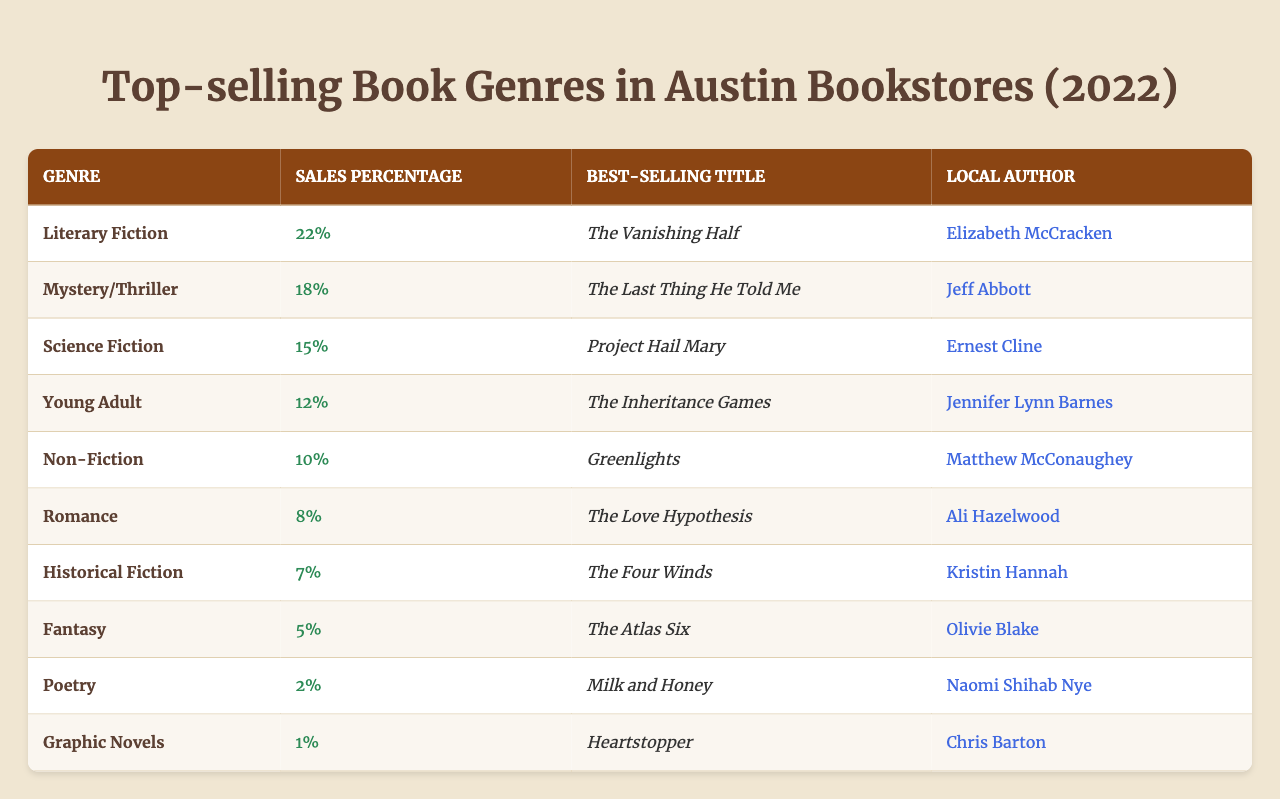What is the best-selling title in the Mystery/Thriller genre? Referring to the table, the row for the Mystery/Thriller genre shows that the best-selling title is "The Last Thing He Told Me."
Answer: The Last Thing He Told Me Which genre has the highest sales percentage? The table lists the Literary Fiction genre with a sales percentage of 22%, which is the highest among all listed genres.
Answer: Literary Fiction How many genres have a sales percentage of 10% or more? By reviewing the table, I can count the genres with sales percentages of 10% or more: Literary Fiction (22%), Mystery/Thriller (18%), Science Fiction (15%), Young Adult (12%), and Non-Fiction (10%). This gives a total of 5 genres.
Answer: 5 Is there a local author for the Fantasy genre? Looking at the table, the Fantasy genre does have a local author listed: Olivie Blake. Therefore, the answer is yes.
Answer: Yes What is the sales percentage difference between Literary Fiction and Poetry? To find the difference, I subtract the sales percentage for Poetry (2%) from Literary Fiction (22%): 22% - 2% = 20%.
Answer: 20% Which genre has the lowest sales percentage and who is the author? Scanning through the table, Graphic Novels have the lowest sales percentage of 1% and the author listed is Chris Barton.
Answer: Graphic Novels, Chris Barton What is the average sales percentage of genres that feature a local author? The genres with local authors are Literary Fiction (22%), Mystery/Thriller (18%), Science Fiction (15%), Young Adult (12%), Non-Fiction (10%), Romance (8%), Historical Fiction (7%), Poetry (2%), and Graphic Novels (1%). The total percentage is 22 + 18 + 15 + 12 + 10 + 8 + 7 + 2 + 1 = 93%. There are 9 genres, so the average is 93% / 9 = 10.33%.
Answer: 10.33% Which genre is more popular: Poetry or Graphic Novels? Comparing the sales percentages shows Poetry at 2% and Graphic Novels at 1%. Since 2% is greater than 1%, Poetry is the more popular genre.
Answer: Poetry How many local authors are associated with genres that sell 10% or more? Scanning the genres that have sales percentages of 10% or more (5 genres total: Literary Fiction, Mystery/Thriller, Science Fiction, Young Adult, Non-Fiction), we find that all these genres list local authors: Elizabeth McCracken, Jeff Abbott, Ernest Cline, Jennifer Lynn Barnes, and Matthew McConaughey—5 local authors in total.
Answer: 5 